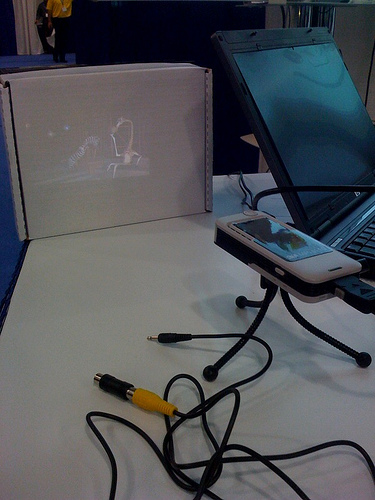<image>What is the image of? I don't know what the image is of, it could be of electronics, a person, cables and laptop, cords, various technology or a phone. What is the image of? I don't know what the image is of. It can be electronics, person or cables and laptop. 